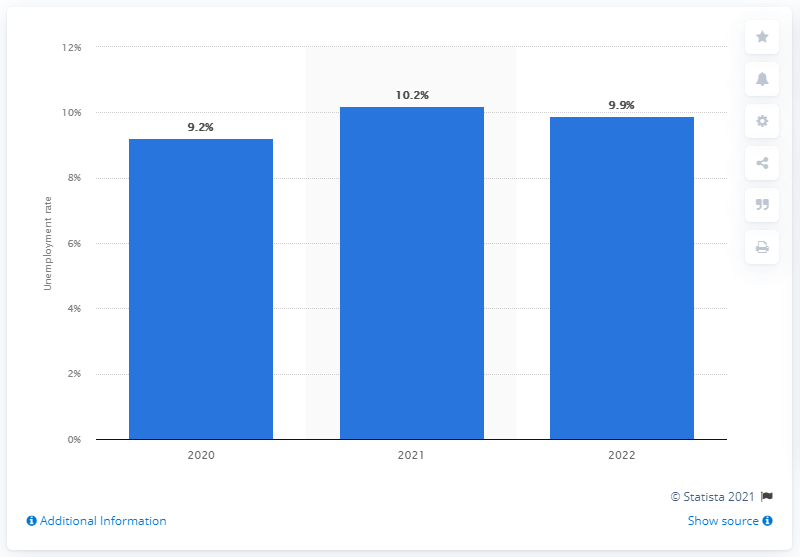Highlight a few significant elements in this photo. The expected unemployment rate in 2022 is projected to drop to 9.9%. In 2020, Italy's unemployment rate was 9.2%. 